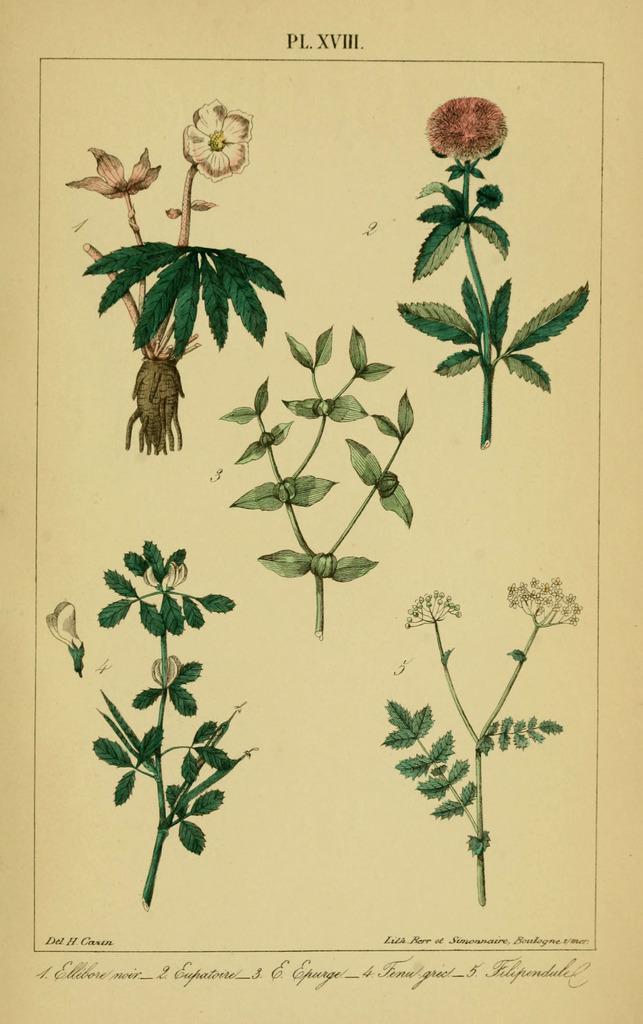Can you describe this image briefly? In the image I can see painting of flowers and plants. I can also see something written on the image. 